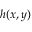<formula> <loc_0><loc_0><loc_500><loc_500>h ( x , y )</formula> 